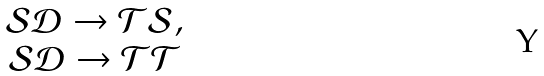Convert formula to latex. <formula><loc_0><loc_0><loc_500><loc_500>\begin{array} { c } \mathcal { S } \mathcal { D } \to \mathcal { T } \mathcal { S } , \\ \mathcal { S } \mathcal { D } \to \mathcal { T } \mathcal { T } \\ \end{array}</formula> 